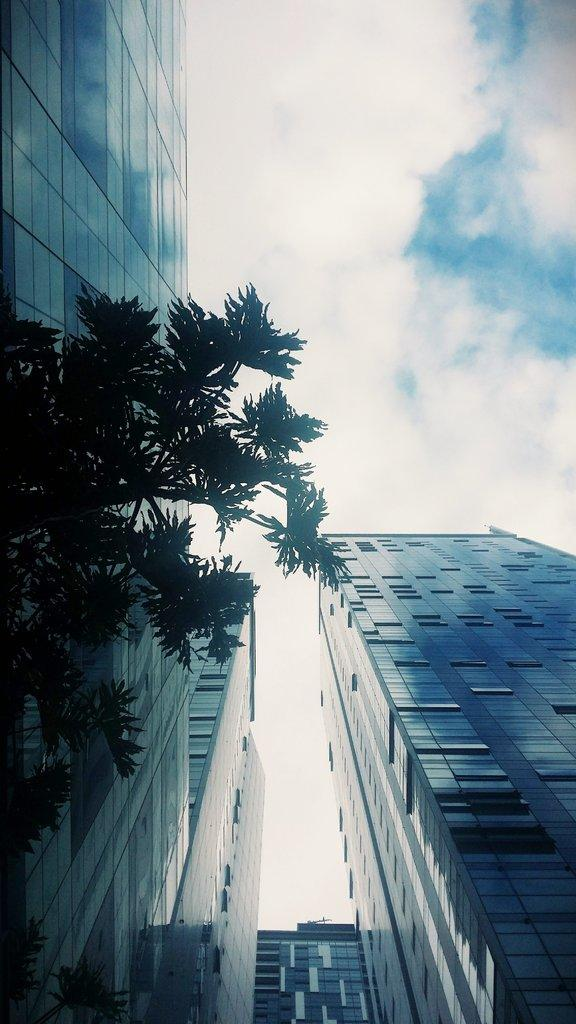What type of structures can be seen in the image? There are buildings in the image. What type of vegetation is present in the image? There is a green color tree in the image. What is visible in the background of the image? The sky is visible in the image. How would you describe the sky in the image? The sky appears to be cloudy. How many tin mice can be seen climbing the buildings in the image? There are no tin mice present in the image; it only features buildings, a green tree, and a cloudy sky. 